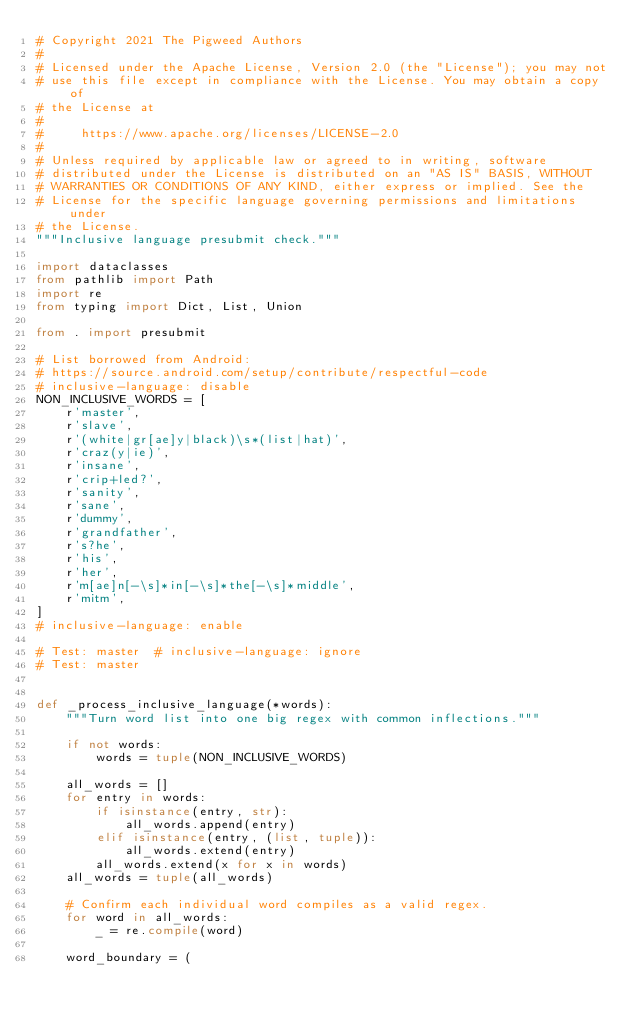Convert code to text. <code><loc_0><loc_0><loc_500><loc_500><_Python_># Copyright 2021 The Pigweed Authors
#
# Licensed under the Apache License, Version 2.0 (the "License"); you may not
# use this file except in compliance with the License. You may obtain a copy of
# the License at
#
#     https://www.apache.org/licenses/LICENSE-2.0
#
# Unless required by applicable law or agreed to in writing, software
# distributed under the License is distributed on an "AS IS" BASIS, WITHOUT
# WARRANTIES OR CONDITIONS OF ANY KIND, either express or implied. See the
# License for the specific language governing permissions and limitations under
# the License.
"""Inclusive language presubmit check."""

import dataclasses
from pathlib import Path
import re
from typing import Dict, List, Union

from . import presubmit

# List borrowed from Android:
# https://source.android.com/setup/contribute/respectful-code
# inclusive-language: disable
NON_INCLUSIVE_WORDS = [
    r'master',
    r'slave',
    r'(white|gr[ae]y|black)\s*(list|hat)',
    r'craz(y|ie)',
    r'insane',
    r'crip+led?',
    r'sanity',
    r'sane',
    r'dummy',
    r'grandfather',
    r's?he',
    r'his',
    r'her',
    r'm[ae]n[-\s]*in[-\s]*the[-\s]*middle',
    r'mitm',
]
# inclusive-language: enable

# Test: master  # inclusive-language: ignore
# Test: master


def _process_inclusive_language(*words):
    """Turn word list into one big regex with common inflections."""

    if not words:
        words = tuple(NON_INCLUSIVE_WORDS)

    all_words = []
    for entry in words:
        if isinstance(entry, str):
            all_words.append(entry)
        elif isinstance(entry, (list, tuple)):
            all_words.extend(entry)
        all_words.extend(x for x in words)
    all_words = tuple(all_words)

    # Confirm each individual word compiles as a valid regex.
    for word in all_words:
        _ = re.compile(word)

    word_boundary = (</code> 